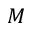Convert formula to latex. <formula><loc_0><loc_0><loc_500><loc_500>M</formula> 